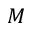Convert formula to latex. <formula><loc_0><loc_0><loc_500><loc_500>M</formula> 